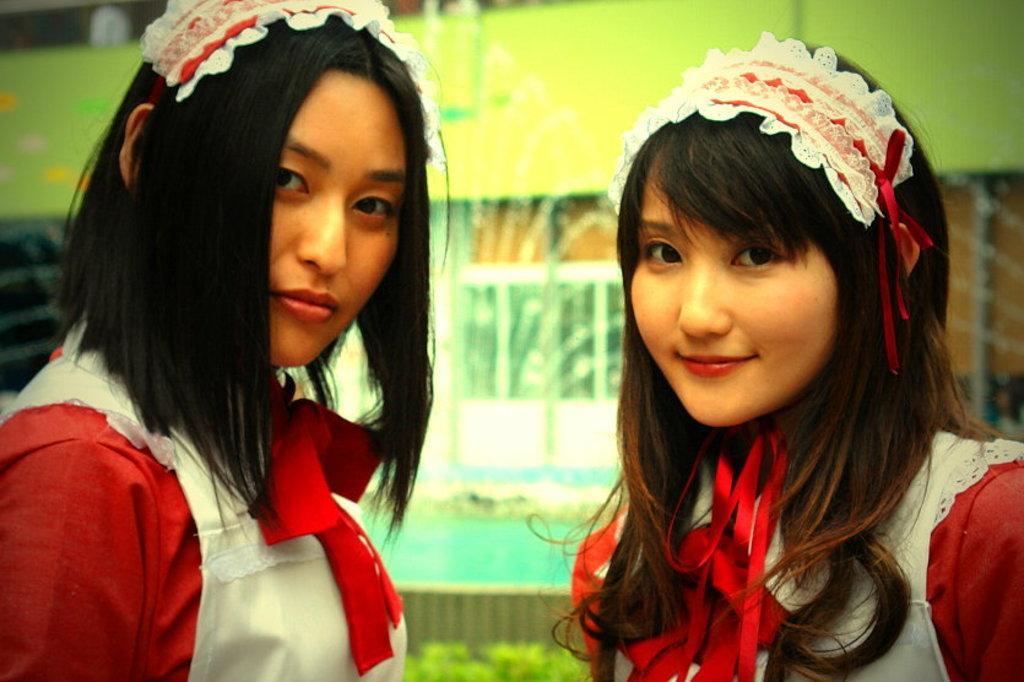Please provide a concise description of this image. In the center of the image we can see two persons are in different costumes. And the right side person is smiling. In the background, we can see it is blurred. 